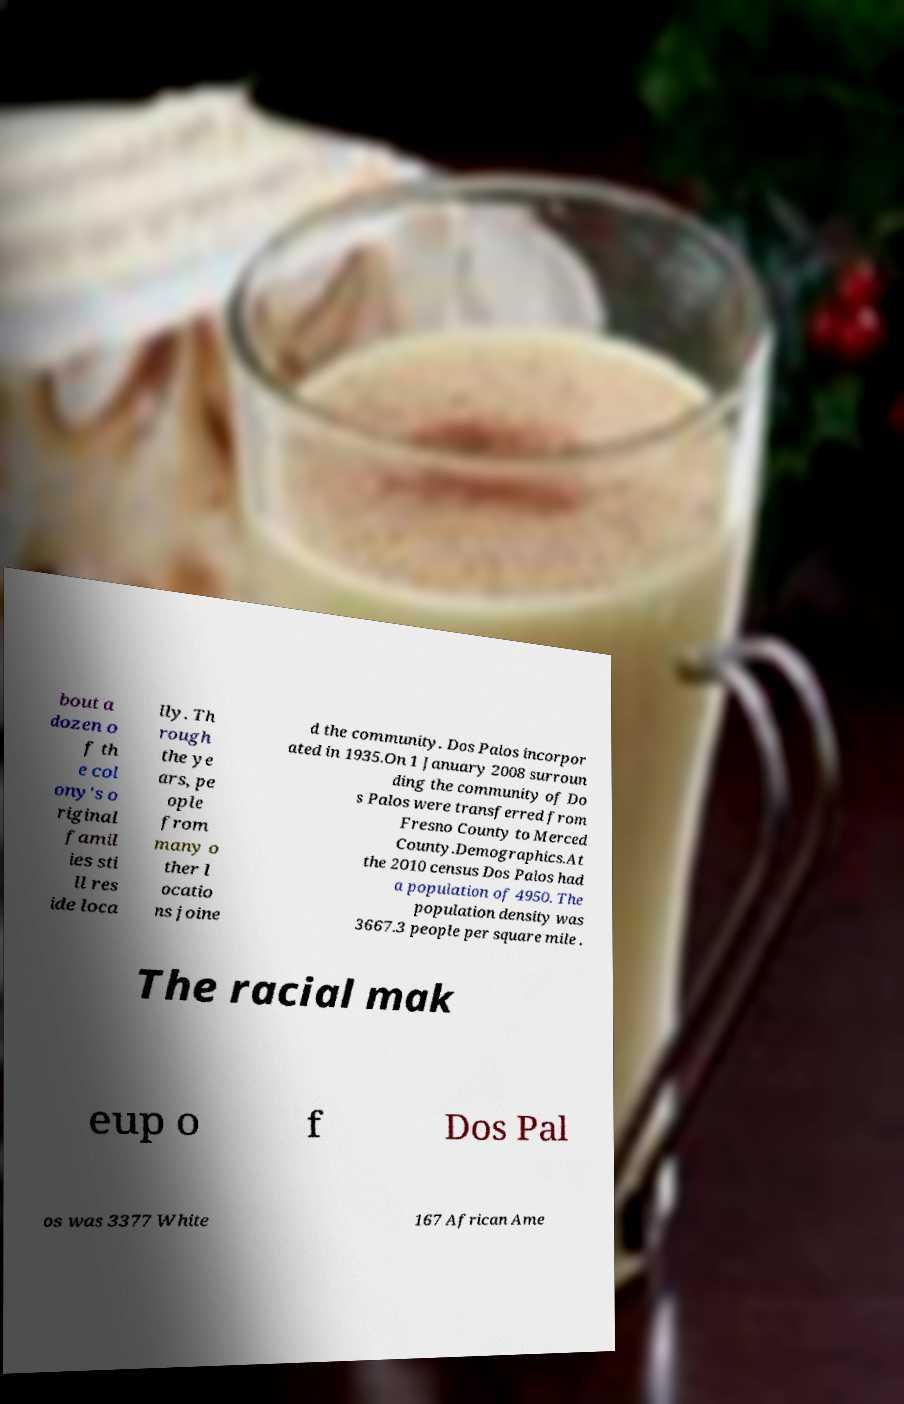Can you read and provide the text displayed in the image?This photo seems to have some interesting text. Can you extract and type it out for me? bout a dozen o f th e col ony's o riginal famil ies sti ll res ide loca lly. Th rough the ye ars, pe ople from many o ther l ocatio ns joine d the community. Dos Palos incorpor ated in 1935.On 1 January 2008 surroun ding the community of Do s Palos were transferred from Fresno County to Merced County.Demographics.At the 2010 census Dos Palos had a population of 4950. The population density was 3667.3 people per square mile . The racial mak eup o f Dos Pal os was 3377 White 167 African Ame 